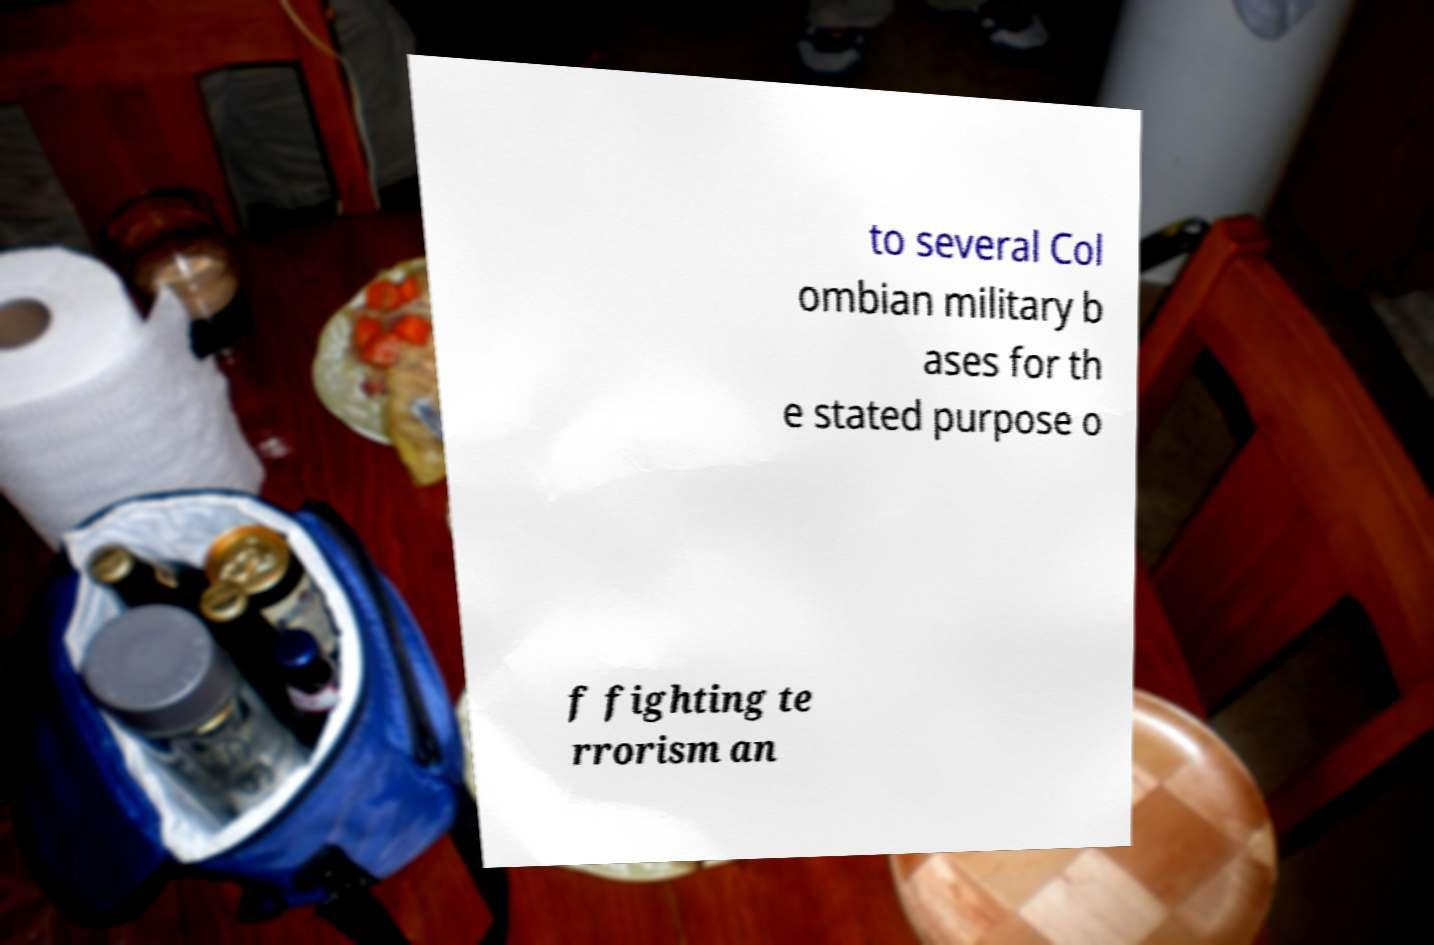Can you read and provide the text displayed in the image?This photo seems to have some interesting text. Can you extract and type it out for me? to several Col ombian military b ases for th e stated purpose o f fighting te rrorism an 